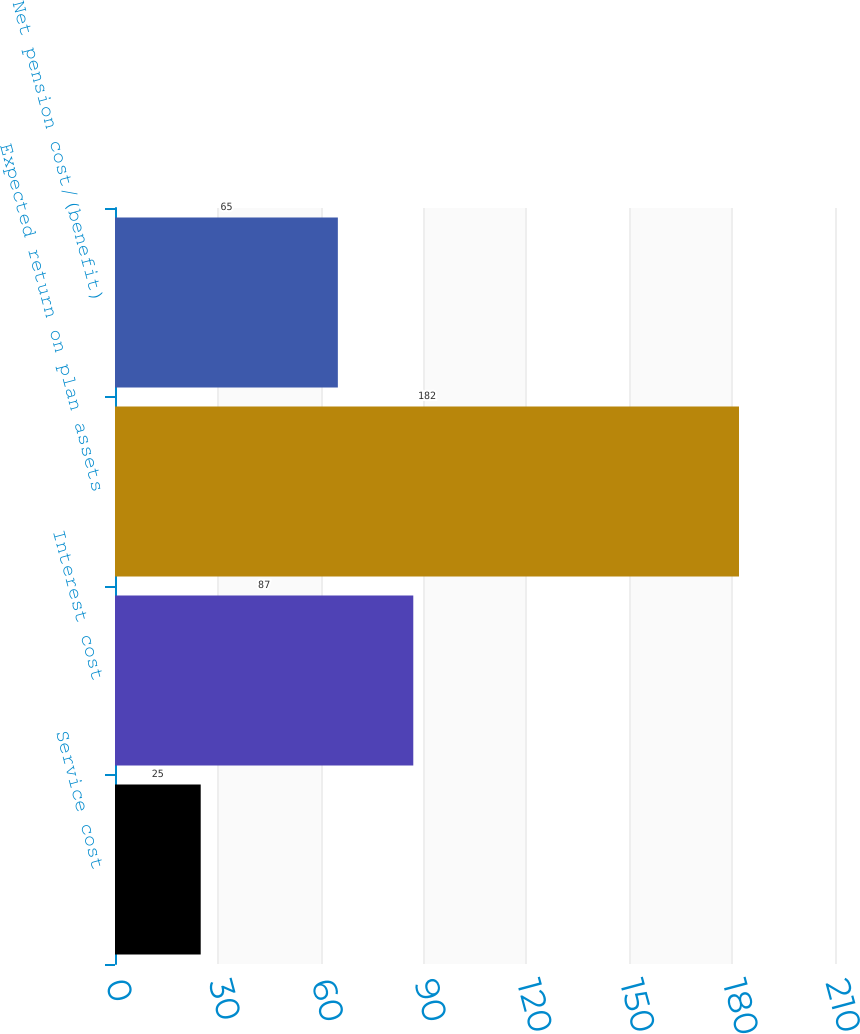<chart> <loc_0><loc_0><loc_500><loc_500><bar_chart><fcel>Service cost<fcel>Interest cost<fcel>Expected return on plan assets<fcel>Net pension cost/(benefit)<nl><fcel>25<fcel>87<fcel>182<fcel>65<nl></chart> 